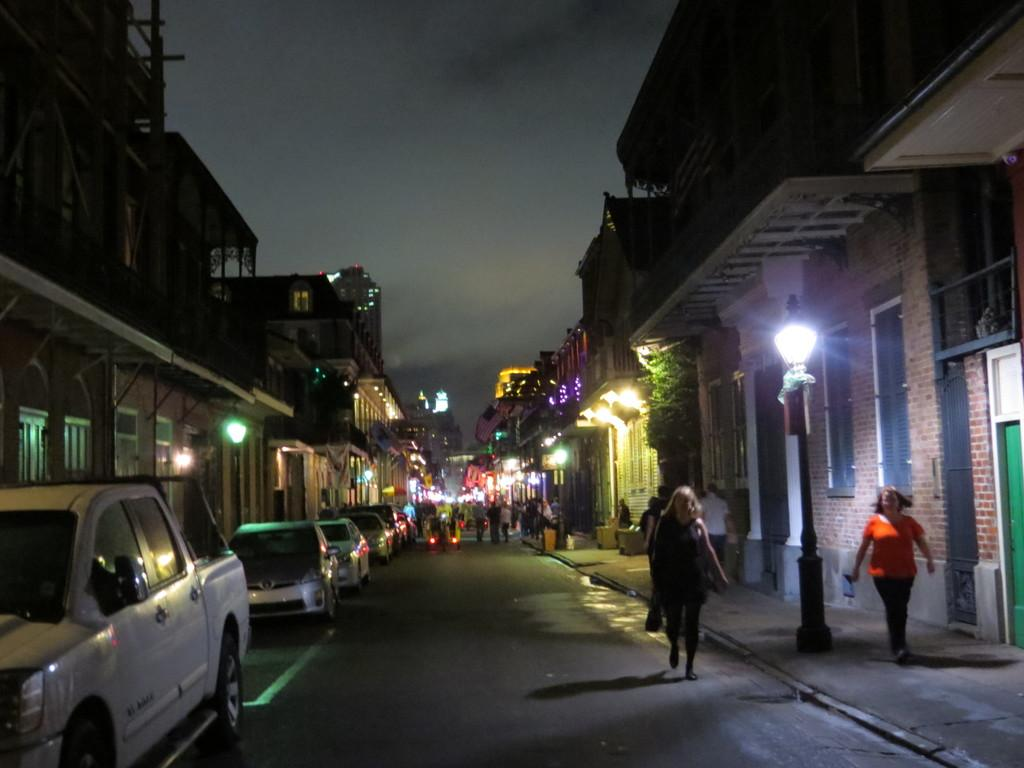What type of structures can be seen in the image? There are buildings in the image. Are there any living beings present in the image? Yes, there are people in the image. What mode of transportation can be seen on the road in the image? There are vehicles on the road in the image. What is visible in the background of the image? The sky is visible in the image. What is the historical significance of the alley in the image? There is no alley present in the image, so it is not possible to discuss its historical significance. 